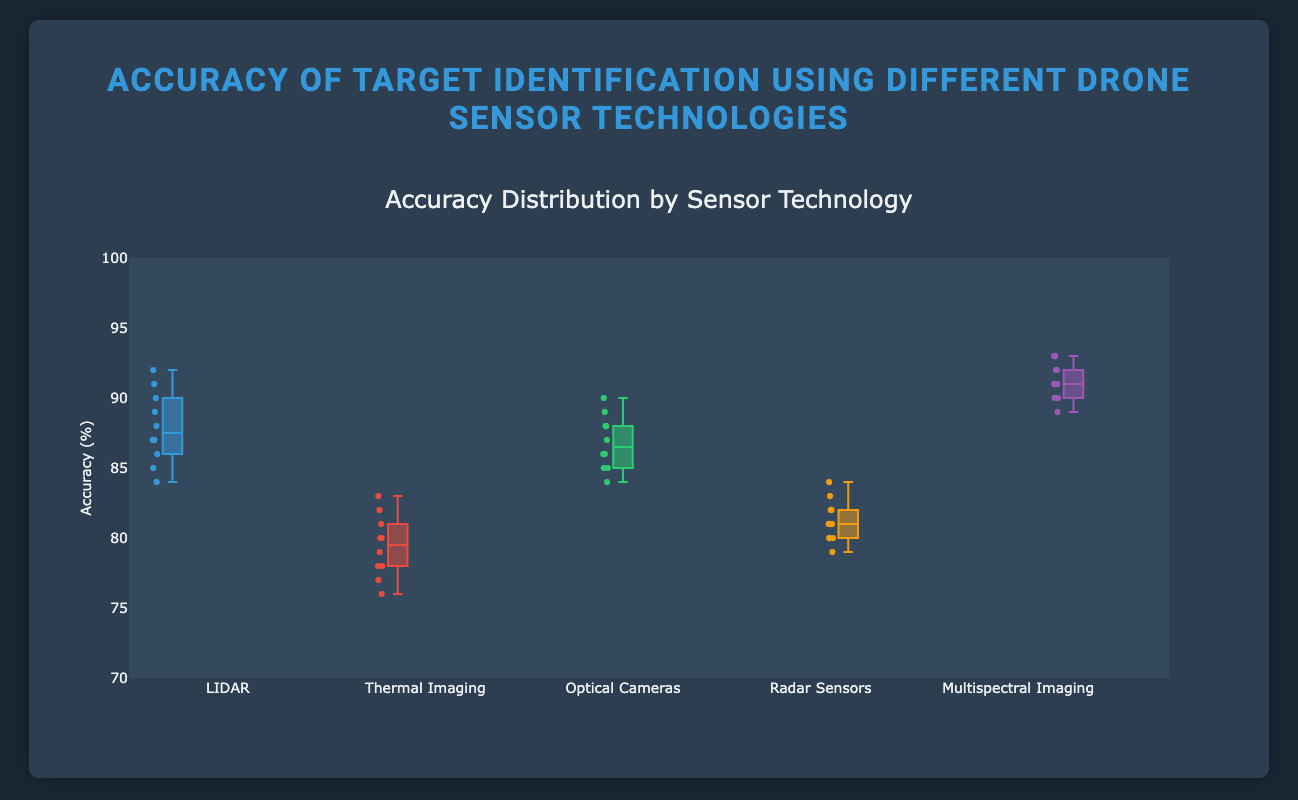Which sensor technology has the highest median accuracy? To find the median accuracy, look at the line inside the box for each sensor technology. The sensor with the highest median line is the one with the highest median accuracy.
Answer: Multispectral Imaging What is the range of accuracy values for LIDAR? To find the range, subtract the minimum value (bottom whisker) from the maximum value (top whisker) for the LIDAR box plot. The minimum value is 84 and the maximum value is 92.
Answer: 8 Which sensor technology has the widest interquartile range (IQR)? The IQR is the range within the box itself, from the lower quartile (Q1) to the upper quartile (Q3). Compare the widths of the boxes for all sensor technologies.
Answer: Optical Cameras How does the median accuracy of Thermal Imaging compare to Radar Sensors? Compare the middle lines of the boxes for Thermal Imaging and Radar Sensors. The median for Thermal Imaging is lower than that of Radar Sensors.
Answer: It is lower What is the overall accuracy range for all sensor technologies? Identify the lowest minimum value and the highest maximum value across all sensor technologies. The lowest minimum value is 76 (Thermal Imaging) and the highest maximum value is 93 (Multispectral Imaging).
Answer: 17 Which sensor technology has the smallest number of outliers? Box plots with fewer points plotted outside the whiskers (outliers) have fewer outliers. Compare the outliers for each sensor technology visually.
Answer: Multispectral Imaging What's the median value of Optical Cameras? Locate the middle line within the box for Optical Cameras. This line represents the median.
Answer: 87 How many sensor technologies have a median accuracy above 85%? Look at the middle line within each box plot. Count the number of box plots where this line is above 85%.
Answer: 4 Which sensor technology has the lowest minimum accuracy? Look at the bottom whisker (the minimum value) of each sensor technology box plot and identify the lowest one.
Answer: Thermal Imaging What is the average accuracy of the Multispectral Imaging sensor technology? To calculate the average accuracy, sum all the accuracy values for Multispectral Imaging and divide by the number of values. (92 + 90 + 91 + 93 + 89 + 91 + 92 + 90 + 91 + 93) / 10 = 912 / 10 = 91.2
Answer: 91.2 